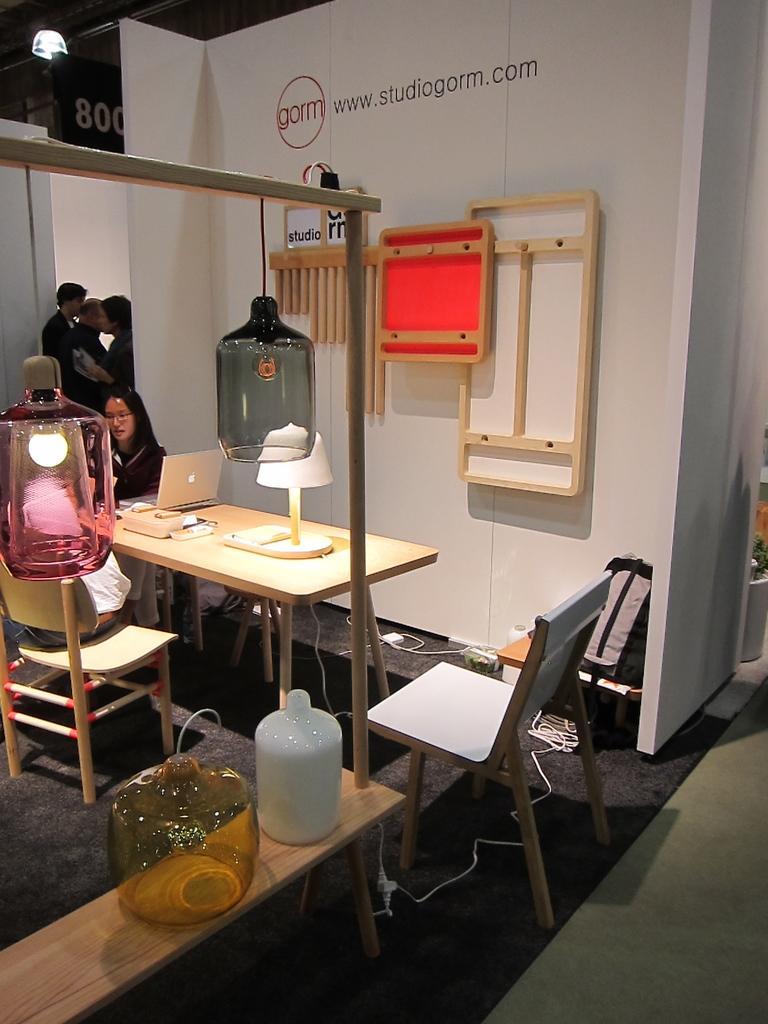Describe this image in one or two sentences. In this image we can see some chairs and two Women are sitting on the chair in front of them there is a table on the table we have papers, books and laptop and different types of bottles are being placed on the table background we can see some people are standing position. 